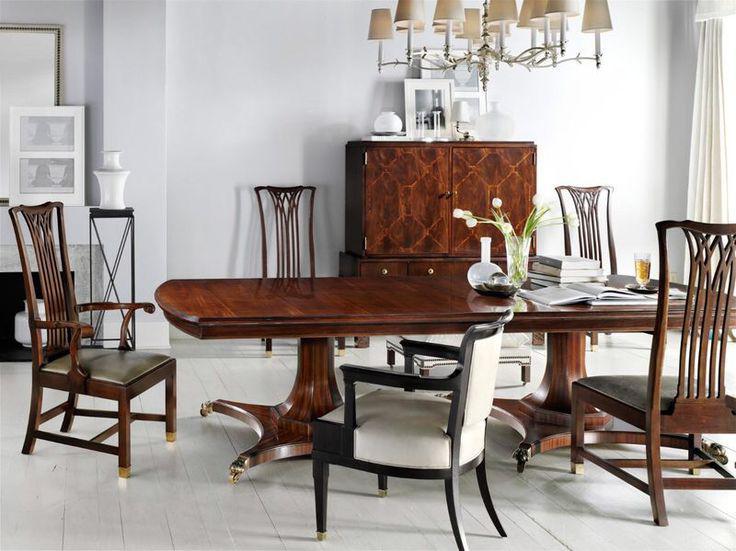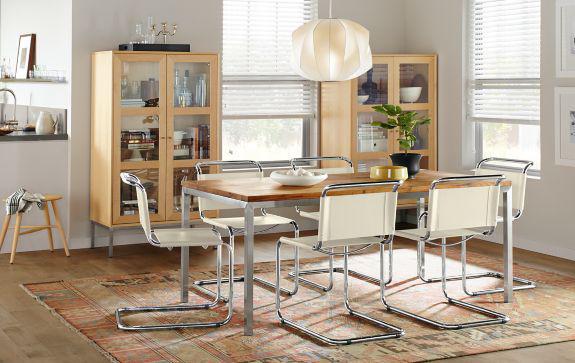The first image is the image on the left, the second image is the image on the right. For the images displayed, is the sentence "One long table is shown with four chairs and one with six chairs." factually correct? Answer yes or no. No. 